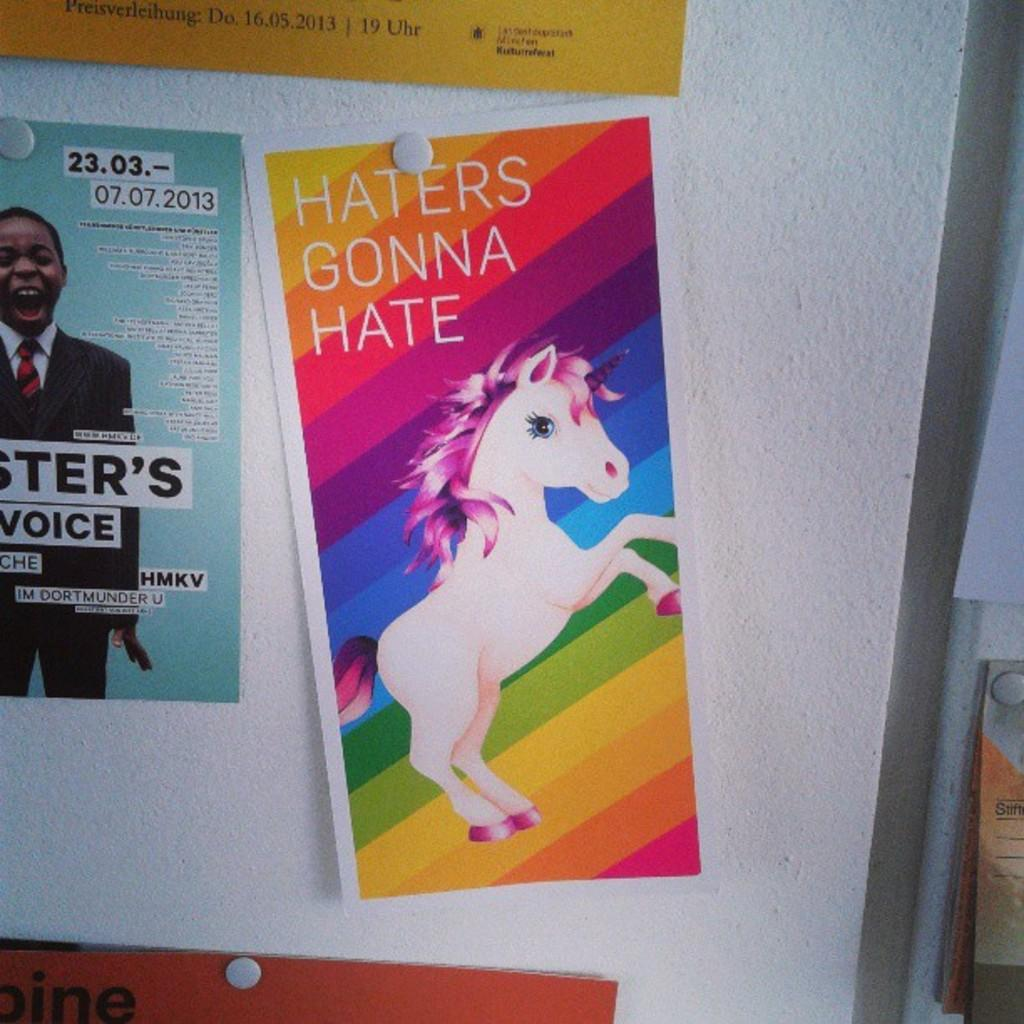What can be seen on the wall in the image? There are posters in the image. How are the posters attached to the wall? The posters are stuck to the wall. Where is the vase placed in the image? There is no vase present in the image. What type of event is taking place in the image? There is no event depicted in the image; it only shows posters stuck to the wall. 